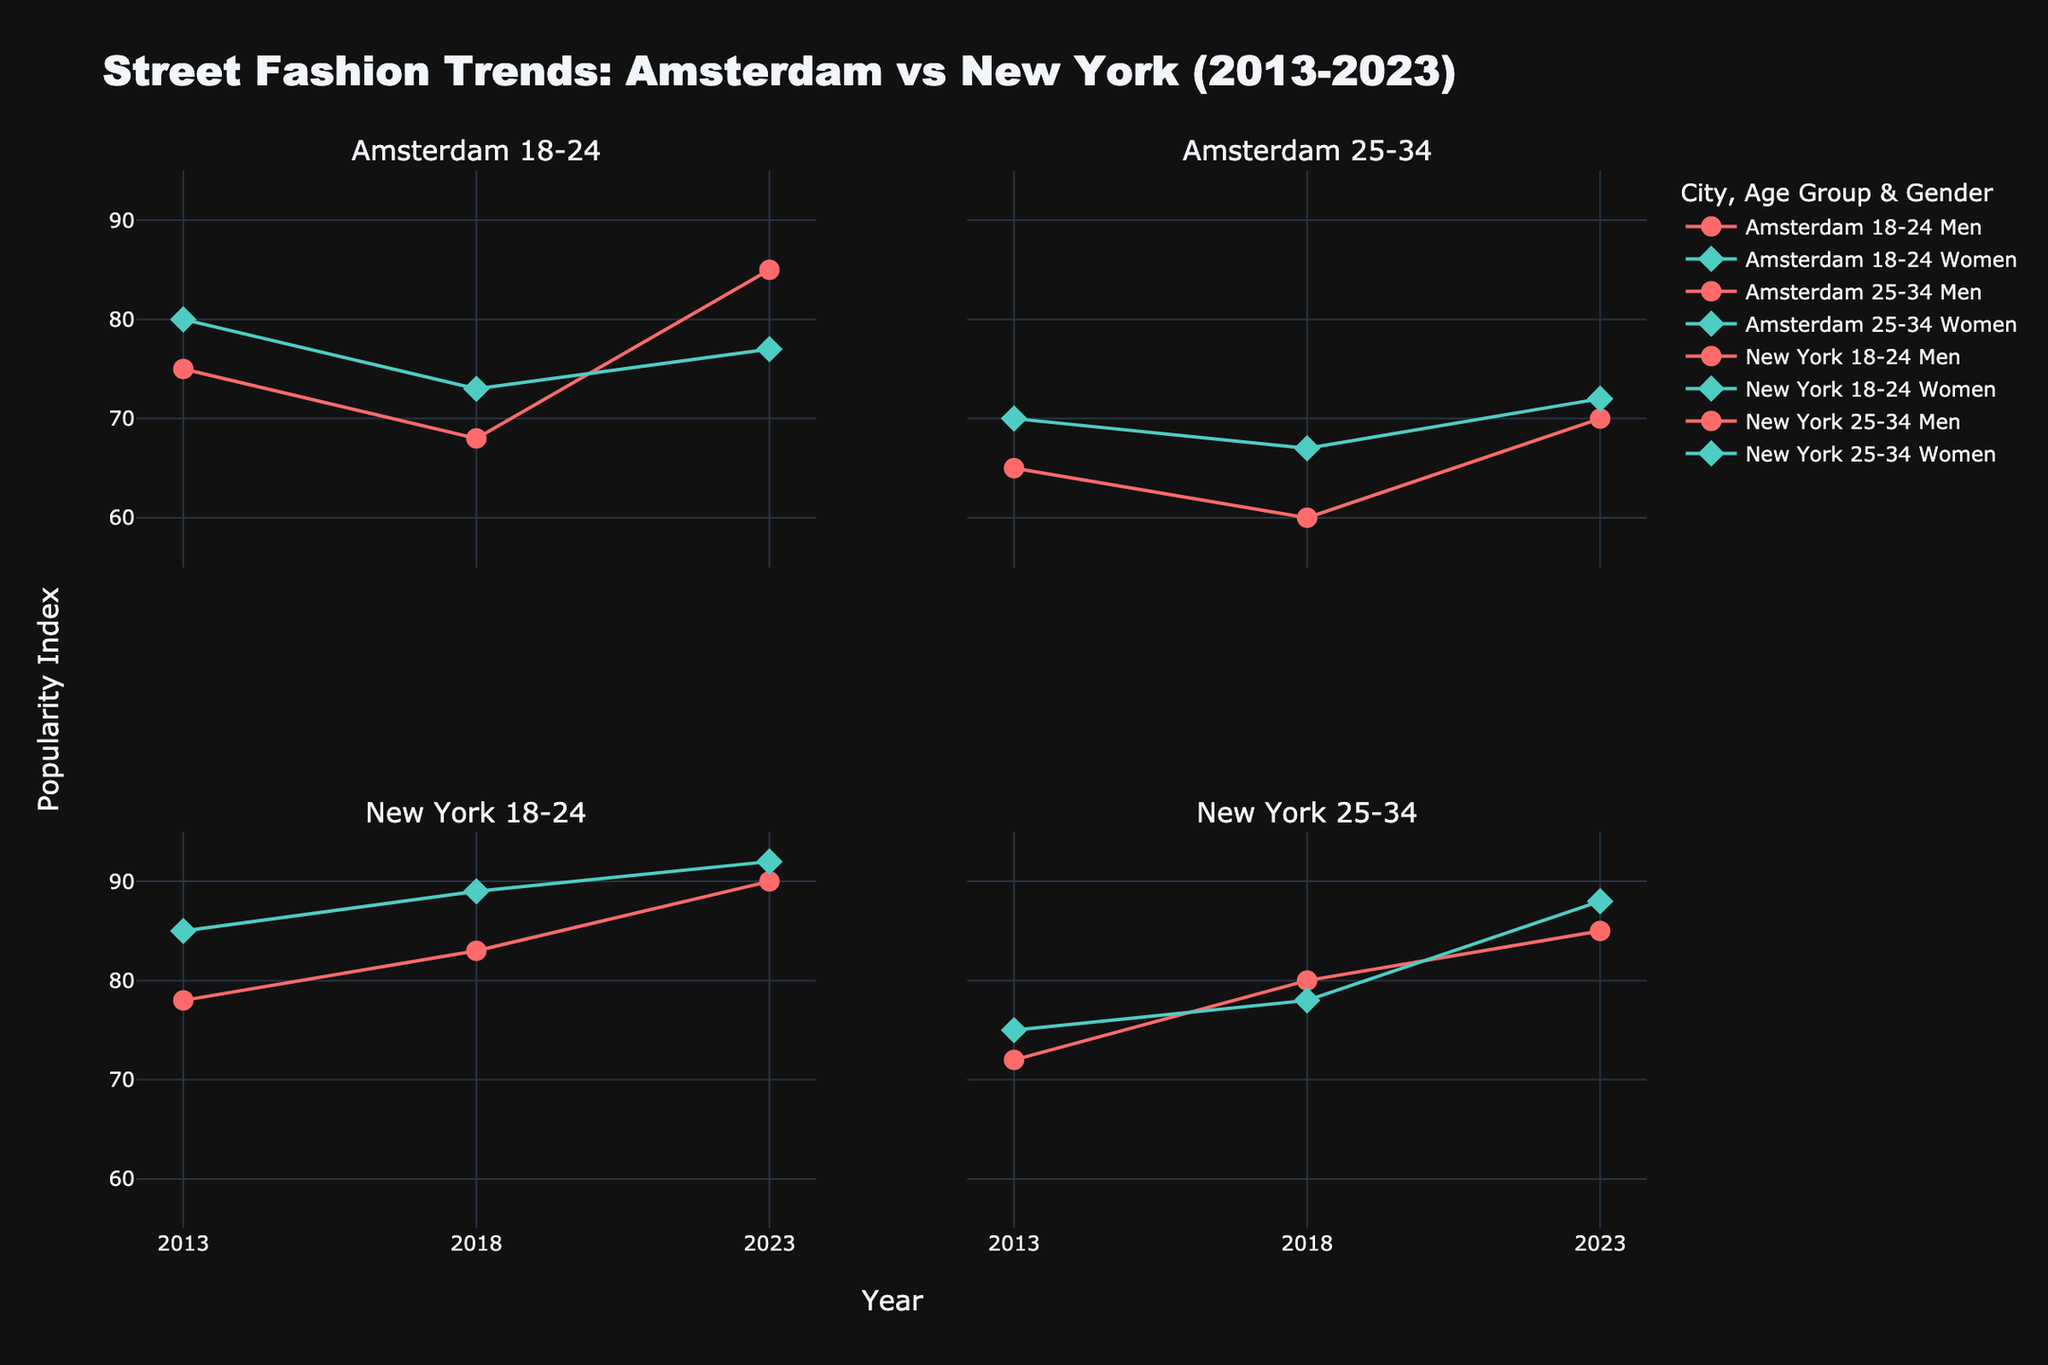What is the title of the figure? The title of the figure is displayed at the top of the plot. It typically summarizes the main subject or the comparison being shown in the plot.
Answer: Street Fashion Trends: Amsterdam vs New York (2013-2023) What are the x-axis and y-axis labels? The x-axis label is positioned at the bottom of the plot, and it indicates the variable plotted along the horizontal axis. The y-axis label is on the left side, representing the variable plotted along the vertical axis.
Answer: The x-axis label is "Year" and the y-axis label is "Popularity Index" Which age group and gender in Amsterdam had the highest popularity index in 2023? For Amsterdam in 2023, look at both 18-24 and 25-34 age groups and compare the values for men and women. The highest value among them is for men aged 18-24.
Answer: Men aged 18-24 What fashion style was most popular in New York for women aged 18-24 in 2023? In the New York 18-24 subplot, search for the data point corresponding to women in 2023, and check the text (style) displayed in the hover information.
Answer: Street Dresses How did the popularity index for men aged 18-24 in Amsterdam change from 2013 to 2023? Examine the Amsterdam 18-24 subplot. Look at the data points representing men in 2013 and 2023, and then note the change in the y-axis value (Popularity Index).
Answer: Increased from 75 to 85 Between Amsterdam and New York, which city exhibited greater overall popularity for women's fashion in the age group 25-34 in 2023? Compare the popularity index for women aged 25-34 in both cities in 2023 from the respective subplots. New York has higher values.
Answer: New York What trend can be observed in the popularity index for men aged 25-34 in New York from 2013 to 2023? Look at the line for men aged 25-34 in New York across the years from 2013 to 2023 to see if it is increasing, decreasing, or steady.
Answer: Increasing What was the most popular style for men aged 18-24 in New York in 2018? In the New York 18-24 subplot, identify the data point for men in 2018 and refer to the hover information to find the style.
Answer: Track Pants Compare the popularity of High-Waisted Shorts in Amsterdam 2018 with Bomber Jackets in New York 2013 for the 18-24 age group. Which was more popular? Check the given popularity index values for High-Waisted Shorts in Amsterdam (18-24 in 2018) and Bomber Jackets in New York (18-24 in 2013).
Answer: Bomber Jackets (78 vs 73) Which city and age group showed the most significant increase in popularity index for a single gender from 2013 to 2023? Review each city's subplot for both age groups and compare the change in values from 2013 to 2023 for either gender to find the most significant increase.
Answer: Men aged 18-24 in New York (+12 from 78 to 90) 